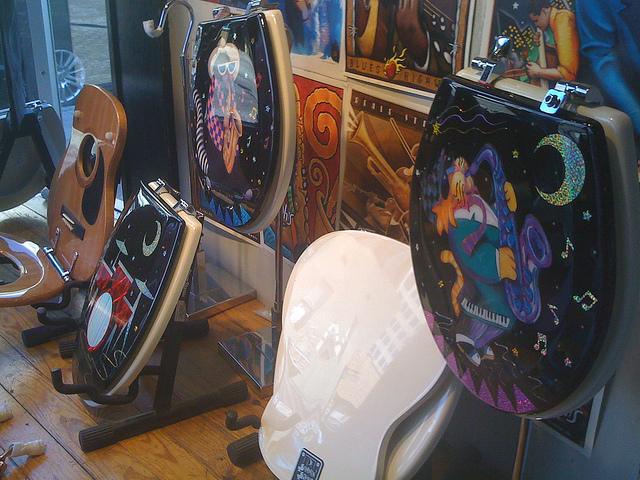How many of the lids are shaped like guitars?
Give a very brief answer. 2. Are the decorated objects toilet seats?
Answer briefly. Yes. Is there any mirror near to the bird?
Quick response, please. No. Is this person who created these artistic?
Keep it brief. Yes. 